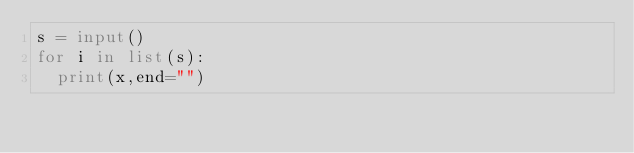<code> <loc_0><loc_0><loc_500><loc_500><_Python_>s = input()
for i in list(s):
  print(x,end="")</code> 